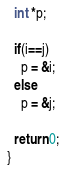<code> <loc_0><loc_0><loc_500><loc_500><_C_>  int *p;

  if(i==j)
    p = &i;
  else
    p = &j;

  return 0;
}
</code> 